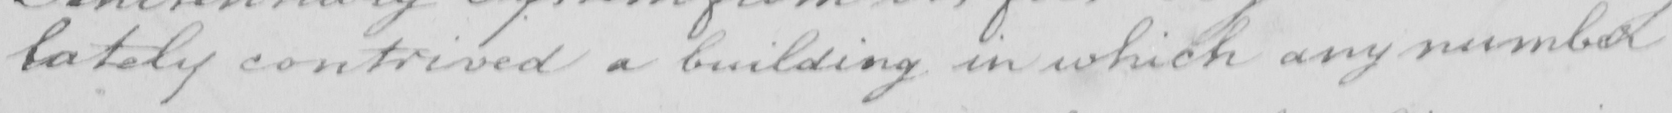Can you read and transcribe this handwriting? lately contrived a building in which any number 